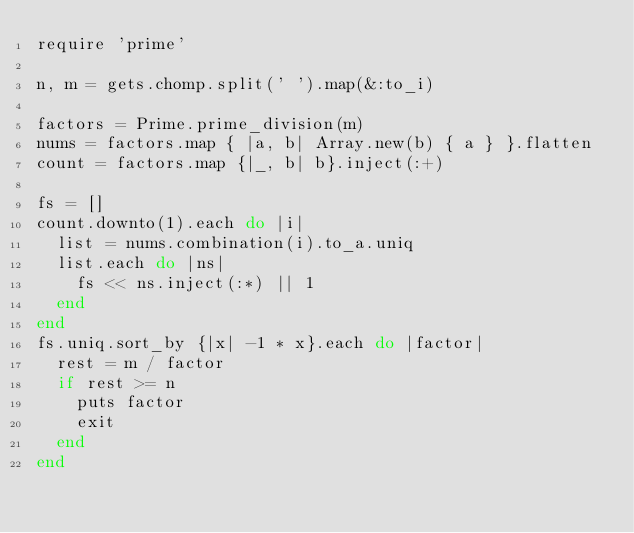<code> <loc_0><loc_0><loc_500><loc_500><_Ruby_>require 'prime'

n, m = gets.chomp.split(' ').map(&:to_i)

factors = Prime.prime_division(m)
nums = factors.map { |a, b| Array.new(b) { a } }.flatten
count = factors.map {|_, b| b}.inject(:+)

fs = []
count.downto(1).each do |i|
  list = nums.combination(i).to_a.uniq
  list.each do |ns|
    fs << ns.inject(:*) || 1
  end
end
fs.uniq.sort_by {|x| -1 * x}.each do |factor|
  rest = m / factor
  if rest >= n
    puts factor
    exit
  end
end
</code> 